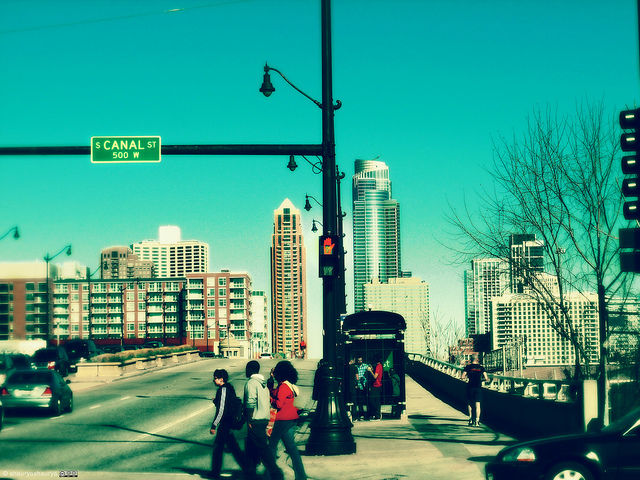Read all the text in this image. S CANAL ST 500 W 